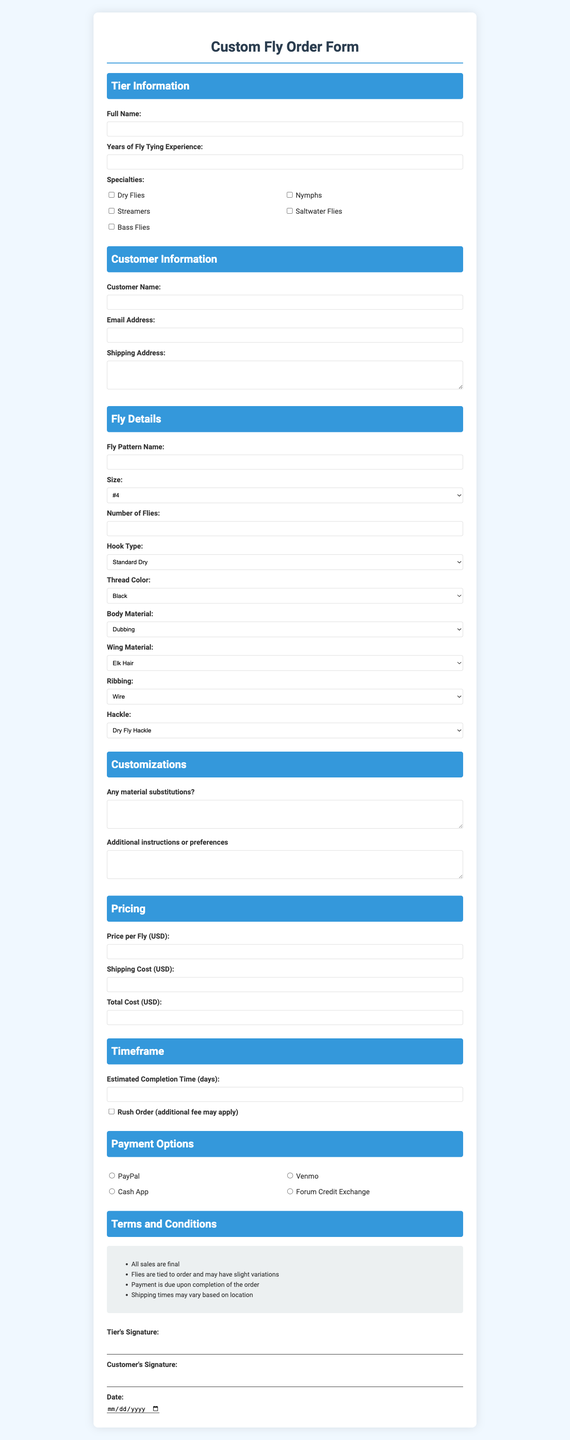What is the title of the form? The title of the form is located at the top of the document, specifying its purpose.
Answer: Custom Fly Order Form How many specialties can a tier select? The document lists multiple specialties for the tier to choose from, reflecting their expertise.
Answer: Multiple What is the size option available for flies? The document specifies various sizes available for the custom flies that the customer can select.
Answer: #4, #6, #8, #10, #12, #14, #16, #18, #20, #22 What is required for the customer’s email? The email section of the document mandates the format needed for the customer's contact information.
Answer: Email Address How long is the estimated completion time for the order? The document requests an input for the completion time, outlining the timeframe for fulfilling orders.
Answer: Estimated Completion Time (days) What payment options are provided? The document includes a section listing various methods available for payment processing.
Answer: PayPal, Venmo, Cash App, Forum Credit Exchange What happens if a rush order is requested? The document mentions an additional condition related to expediting the order, hinting at potential extra costs.
Answer: Additional fee may apply What are the terms regarding sales? The document enumerates important conditions that govern the transaction between the tier and the customer.
Answer: All sales are final Who must sign the document? The document specifies signatures required to validate the order from both parties involved.
Answer: Tier's Signature, Customer's Signature 